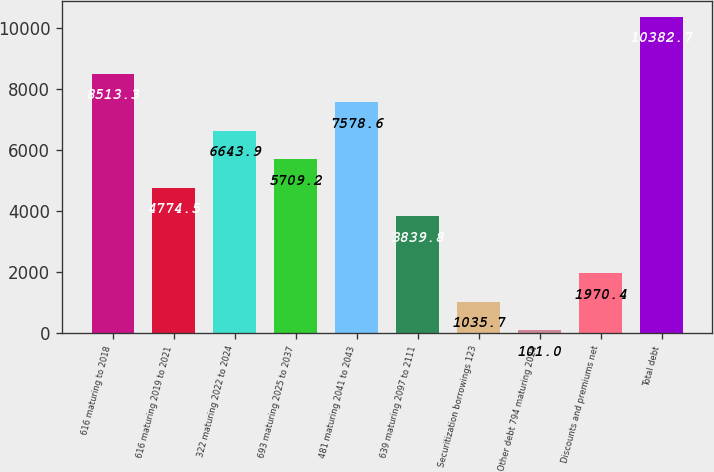<chart> <loc_0><loc_0><loc_500><loc_500><bar_chart><fcel>616 maturing to 2018<fcel>616 maturing 2019 to 2021<fcel>322 maturing 2022 to 2024<fcel>693 maturing 2025 to 2037<fcel>481 maturing 2041 to 2043<fcel>639 maturing 2097 to 2111<fcel>Securitization borrowings 123<fcel>Other debt 794 maturing 2024<fcel>Discounts and premiums net<fcel>Total debt<nl><fcel>8513.3<fcel>4774.5<fcel>6643.9<fcel>5709.2<fcel>7578.6<fcel>3839.8<fcel>1035.7<fcel>101<fcel>1970.4<fcel>10382.7<nl></chart> 